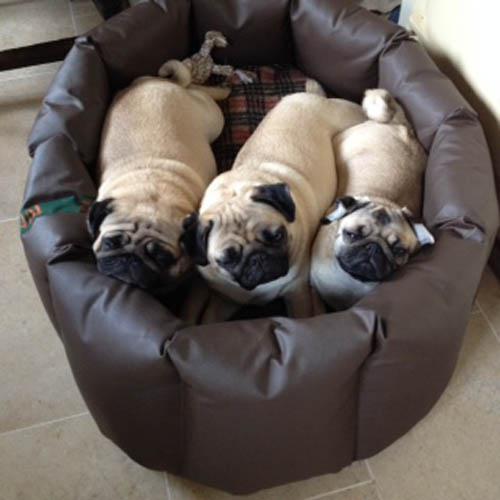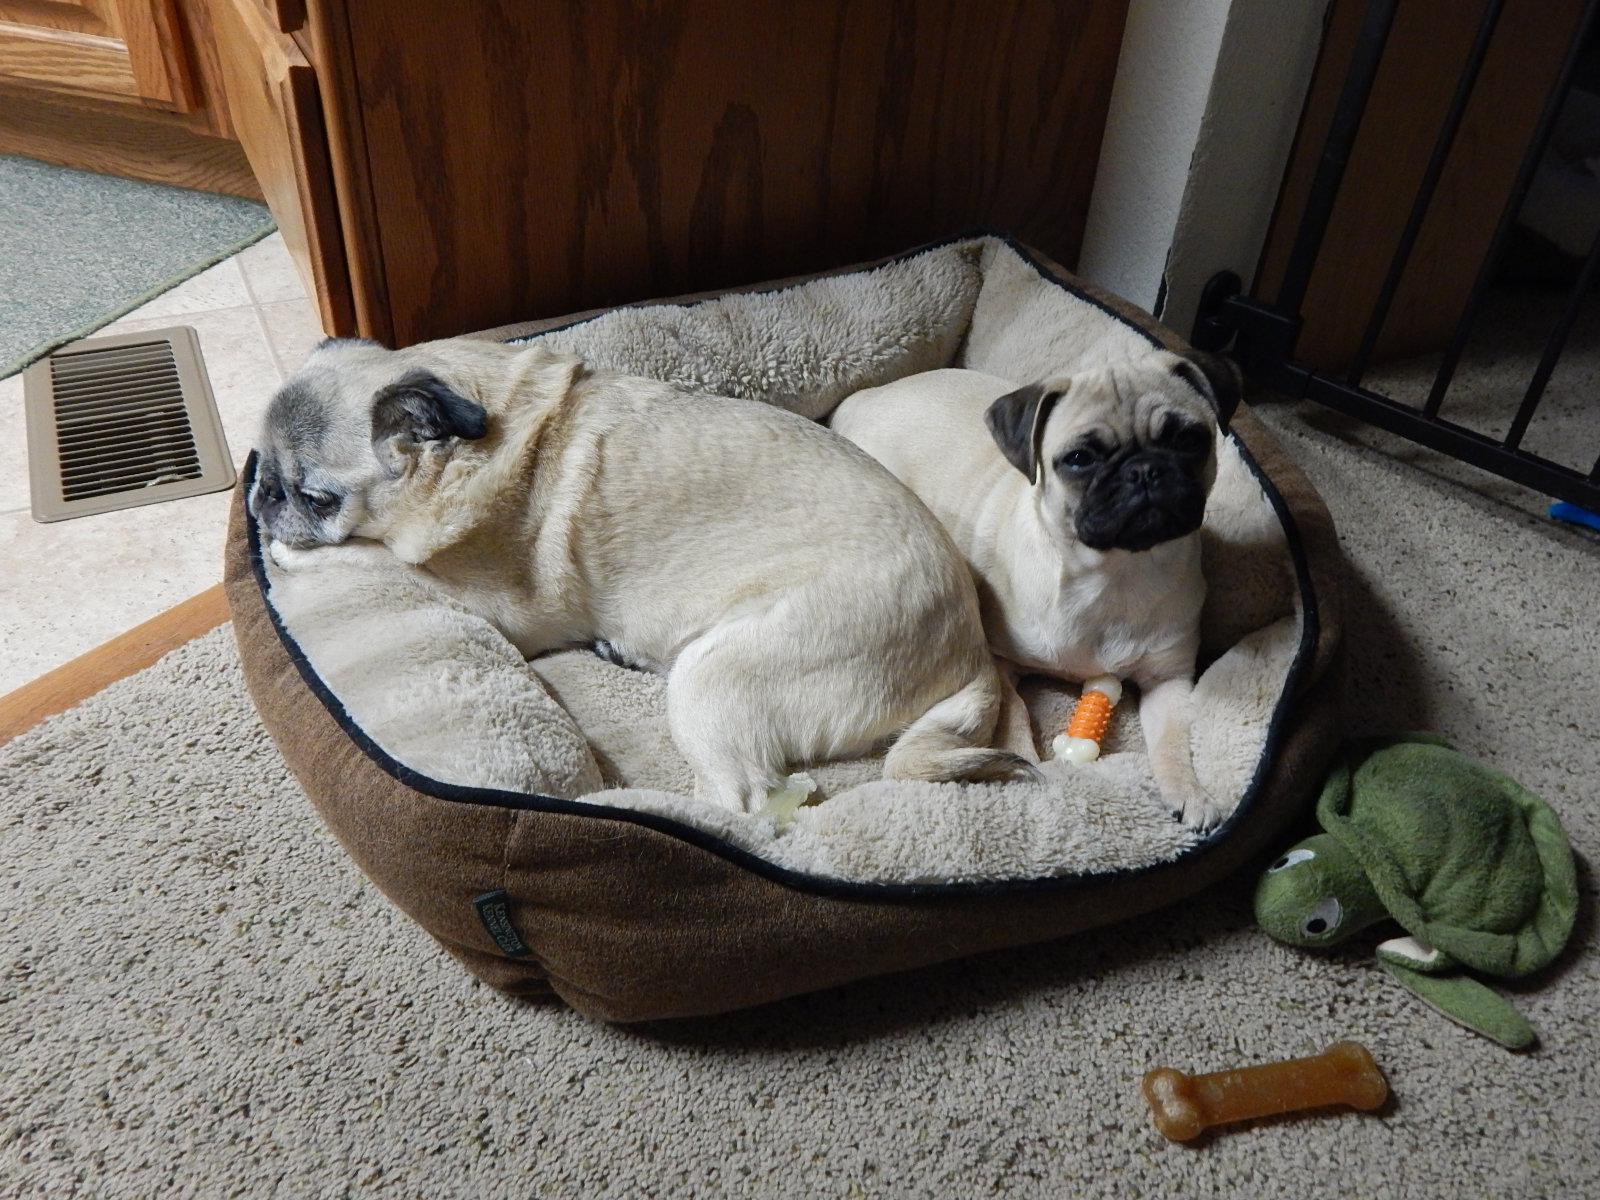The first image is the image on the left, the second image is the image on the right. For the images shown, is this caption "All dogs are in soft-sided containers, and all dogs are light tan with dark faces." true? Answer yes or no. Yes. The first image is the image on the left, the second image is the image on the right. Considering the images on both sides, is "There are at least four pugs." valid? Answer yes or no. Yes. 